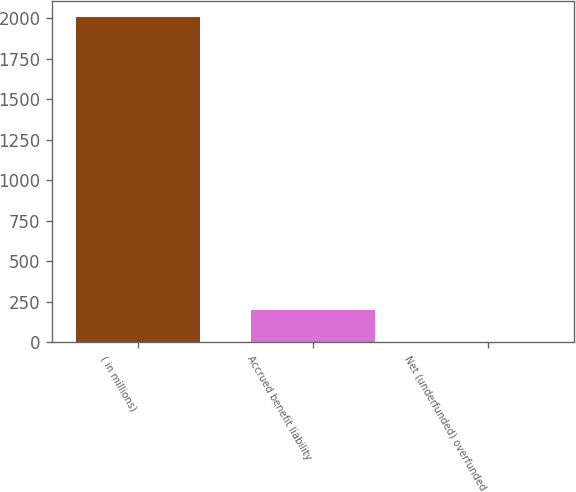Convert chart to OTSL. <chart><loc_0><loc_0><loc_500><loc_500><bar_chart><fcel>( in millions)<fcel>Accrued benefit liability<fcel>Net (underfunded) overfunded<nl><fcel>2007<fcel>201.6<fcel>1<nl></chart> 